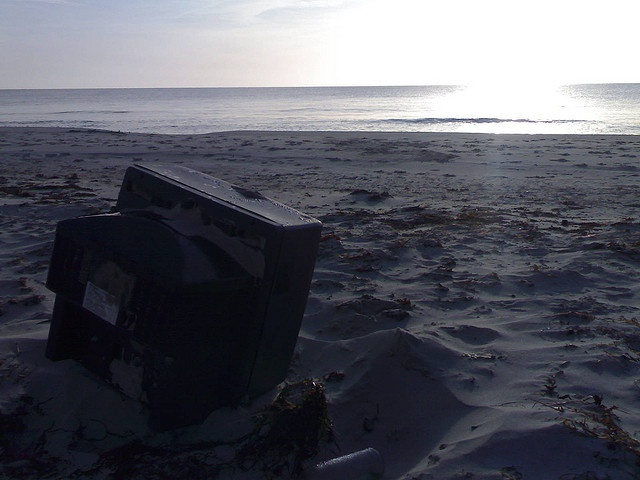Describe the objects in this image and their specific colors. I can see a tv in darkgray, black, and gray tones in this image. 